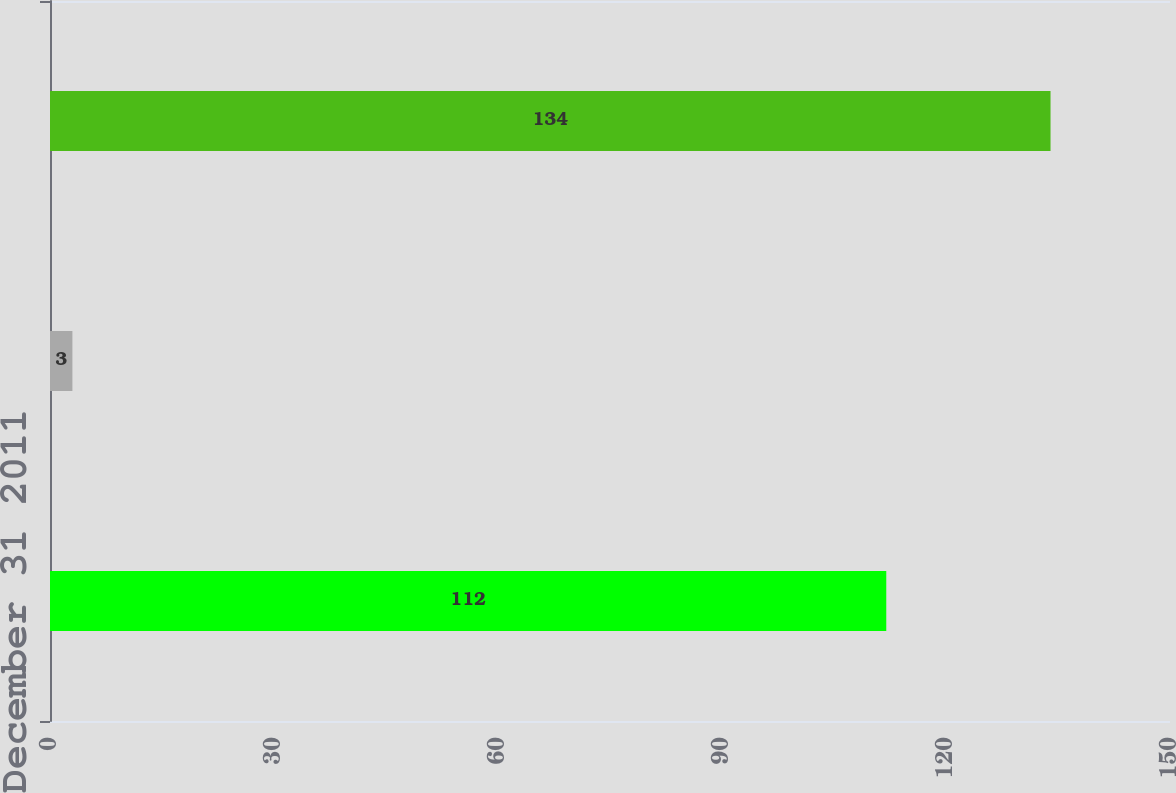<chart> <loc_0><loc_0><loc_500><loc_500><bar_chart><fcel>December 31 2011<fcel>Purchases<fcel>December 28 2013<nl><fcel>112<fcel>3<fcel>134<nl></chart> 